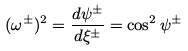<formula> <loc_0><loc_0><loc_500><loc_500>( \omega ^ { \pm } ) ^ { 2 } = \frac { d \psi ^ { \pm } } { d \xi ^ { \pm } } = \cos ^ { 2 } \psi ^ { \pm }</formula> 